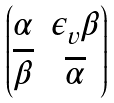Convert formula to latex. <formula><loc_0><loc_0><loc_500><loc_500>\begin{pmatrix} \alpha & \epsilon _ { v } \beta \\ \overline { \beta } & \overline { \alpha } \end{pmatrix}</formula> 